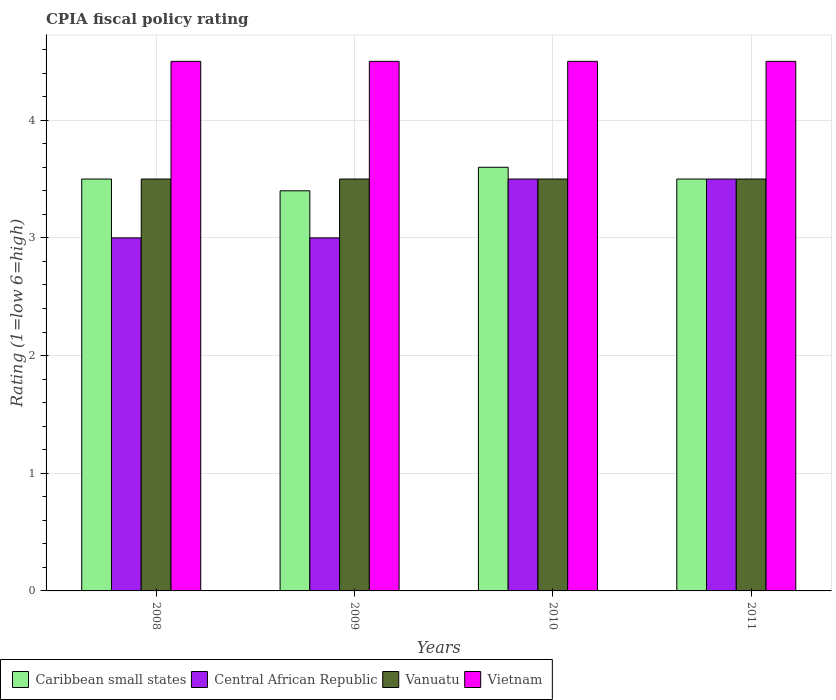How many groups of bars are there?
Provide a short and direct response. 4. Are the number of bars on each tick of the X-axis equal?
Keep it short and to the point. Yes. What is the label of the 4th group of bars from the left?
Your response must be concise. 2011. In how many cases, is the number of bars for a given year not equal to the number of legend labels?
Your answer should be very brief. 0. What is the CPIA rating in Central African Republic in 2008?
Offer a very short reply. 3. Across all years, what is the maximum CPIA rating in Vanuatu?
Offer a very short reply. 3.5. Across all years, what is the minimum CPIA rating in Vanuatu?
Offer a terse response. 3.5. In which year was the CPIA rating in Central African Republic maximum?
Provide a succinct answer. 2010. What is the total CPIA rating in Vietnam in the graph?
Offer a terse response. 18. What is the difference between the CPIA rating in Caribbean small states in 2008 and that in 2011?
Keep it short and to the point. 0. In how many years, is the CPIA rating in Central African Republic greater than 2.2?
Your response must be concise. 4. Is the CPIA rating in Vanuatu in 2009 less than that in 2011?
Offer a very short reply. No. Is the difference between the CPIA rating in Central African Republic in 2010 and 2011 greater than the difference between the CPIA rating in Vietnam in 2010 and 2011?
Keep it short and to the point. No. What is the difference between the highest and the lowest CPIA rating in Central African Republic?
Provide a succinct answer. 0.5. Is the sum of the CPIA rating in Vietnam in 2009 and 2011 greater than the maximum CPIA rating in Caribbean small states across all years?
Offer a very short reply. Yes. Is it the case that in every year, the sum of the CPIA rating in Vanuatu and CPIA rating in Central African Republic is greater than the sum of CPIA rating in Vietnam and CPIA rating in Caribbean small states?
Provide a short and direct response. No. What does the 2nd bar from the left in 2009 represents?
Offer a terse response. Central African Republic. What does the 1st bar from the right in 2009 represents?
Give a very brief answer. Vietnam. Is it the case that in every year, the sum of the CPIA rating in Central African Republic and CPIA rating in Vietnam is greater than the CPIA rating in Vanuatu?
Give a very brief answer. Yes. What is the difference between two consecutive major ticks on the Y-axis?
Offer a very short reply. 1. Are the values on the major ticks of Y-axis written in scientific E-notation?
Your answer should be very brief. No. Does the graph contain any zero values?
Offer a very short reply. No. Does the graph contain grids?
Keep it short and to the point. Yes. Where does the legend appear in the graph?
Give a very brief answer. Bottom left. What is the title of the graph?
Provide a short and direct response. CPIA fiscal policy rating. What is the label or title of the X-axis?
Offer a very short reply. Years. What is the label or title of the Y-axis?
Keep it short and to the point. Rating (1=low 6=high). What is the Rating (1=low 6=high) of Vanuatu in 2008?
Offer a terse response. 3.5. What is the Rating (1=low 6=high) of Vietnam in 2008?
Make the answer very short. 4.5. What is the Rating (1=low 6=high) of Vietnam in 2009?
Your answer should be very brief. 4.5. What is the Rating (1=low 6=high) in Caribbean small states in 2010?
Keep it short and to the point. 3.6. What is the Rating (1=low 6=high) of Central African Republic in 2010?
Your answer should be compact. 3.5. What is the Rating (1=low 6=high) in Caribbean small states in 2011?
Your response must be concise. 3.5. What is the Rating (1=low 6=high) of Vanuatu in 2011?
Offer a terse response. 3.5. What is the Rating (1=low 6=high) of Vietnam in 2011?
Your response must be concise. 4.5. Across all years, what is the minimum Rating (1=low 6=high) of Caribbean small states?
Keep it short and to the point. 3.4. Across all years, what is the minimum Rating (1=low 6=high) in Vietnam?
Your response must be concise. 4.5. What is the total Rating (1=low 6=high) in Caribbean small states in the graph?
Keep it short and to the point. 14. What is the total Rating (1=low 6=high) in Vietnam in the graph?
Provide a succinct answer. 18. What is the difference between the Rating (1=low 6=high) of Central African Republic in 2008 and that in 2009?
Ensure brevity in your answer.  0. What is the difference between the Rating (1=low 6=high) in Vietnam in 2008 and that in 2009?
Provide a short and direct response. 0. What is the difference between the Rating (1=low 6=high) in Caribbean small states in 2008 and that in 2010?
Keep it short and to the point. -0.1. What is the difference between the Rating (1=low 6=high) in Central African Republic in 2008 and that in 2010?
Give a very brief answer. -0.5. What is the difference between the Rating (1=low 6=high) of Vanuatu in 2008 and that in 2010?
Your answer should be compact. 0. What is the difference between the Rating (1=low 6=high) in Vietnam in 2008 and that in 2010?
Your answer should be compact. 0. What is the difference between the Rating (1=low 6=high) of Caribbean small states in 2008 and that in 2011?
Make the answer very short. 0. What is the difference between the Rating (1=low 6=high) of Vanuatu in 2008 and that in 2011?
Provide a short and direct response. 0. What is the difference between the Rating (1=low 6=high) of Vietnam in 2008 and that in 2011?
Give a very brief answer. 0. What is the difference between the Rating (1=low 6=high) of Caribbean small states in 2009 and that in 2010?
Your answer should be compact. -0.2. What is the difference between the Rating (1=low 6=high) of Caribbean small states in 2009 and that in 2011?
Your response must be concise. -0.1. What is the difference between the Rating (1=low 6=high) in Vanuatu in 2009 and that in 2011?
Your answer should be very brief. 0. What is the difference between the Rating (1=low 6=high) of Vietnam in 2009 and that in 2011?
Keep it short and to the point. 0. What is the difference between the Rating (1=low 6=high) of Caribbean small states in 2010 and that in 2011?
Your response must be concise. 0.1. What is the difference between the Rating (1=low 6=high) of Central African Republic in 2010 and that in 2011?
Your answer should be very brief. 0. What is the difference between the Rating (1=low 6=high) in Vanuatu in 2010 and that in 2011?
Offer a terse response. 0. What is the difference between the Rating (1=low 6=high) in Vietnam in 2010 and that in 2011?
Make the answer very short. 0. What is the difference between the Rating (1=low 6=high) in Caribbean small states in 2008 and the Rating (1=low 6=high) in Central African Republic in 2009?
Provide a short and direct response. 0.5. What is the difference between the Rating (1=low 6=high) of Central African Republic in 2008 and the Rating (1=low 6=high) of Vanuatu in 2009?
Your answer should be very brief. -0.5. What is the difference between the Rating (1=low 6=high) in Central African Republic in 2008 and the Rating (1=low 6=high) in Vietnam in 2009?
Your answer should be very brief. -1.5. What is the difference between the Rating (1=low 6=high) in Caribbean small states in 2008 and the Rating (1=low 6=high) in Vietnam in 2010?
Your response must be concise. -1. What is the difference between the Rating (1=low 6=high) in Central African Republic in 2008 and the Rating (1=low 6=high) in Vietnam in 2011?
Make the answer very short. -1.5. What is the difference between the Rating (1=low 6=high) in Vanuatu in 2008 and the Rating (1=low 6=high) in Vietnam in 2011?
Your answer should be compact. -1. What is the difference between the Rating (1=low 6=high) in Caribbean small states in 2009 and the Rating (1=low 6=high) in Central African Republic in 2010?
Offer a terse response. -0.1. What is the difference between the Rating (1=low 6=high) of Central African Republic in 2009 and the Rating (1=low 6=high) of Vietnam in 2010?
Offer a very short reply. -1.5. What is the difference between the Rating (1=low 6=high) of Caribbean small states in 2009 and the Rating (1=low 6=high) of Central African Republic in 2011?
Keep it short and to the point. -0.1. What is the difference between the Rating (1=low 6=high) of Vanuatu in 2009 and the Rating (1=low 6=high) of Vietnam in 2011?
Provide a short and direct response. -1. What is the difference between the Rating (1=low 6=high) in Caribbean small states in 2010 and the Rating (1=low 6=high) in Vanuatu in 2011?
Offer a terse response. 0.1. What is the difference between the Rating (1=low 6=high) in Caribbean small states in 2010 and the Rating (1=low 6=high) in Vietnam in 2011?
Offer a terse response. -0.9. What is the difference between the Rating (1=low 6=high) in Central African Republic in 2010 and the Rating (1=low 6=high) in Vanuatu in 2011?
Offer a terse response. 0. What is the difference between the Rating (1=low 6=high) in Central African Republic in 2010 and the Rating (1=low 6=high) in Vietnam in 2011?
Your answer should be compact. -1. What is the difference between the Rating (1=low 6=high) in Vanuatu in 2010 and the Rating (1=low 6=high) in Vietnam in 2011?
Offer a terse response. -1. What is the average Rating (1=low 6=high) in Central African Republic per year?
Keep it short and to the point. 3.25. What is the average Rating (1=low 6=high) of Vanuatu per year?
Provide a short and direct response. 3.5. In the year 2008, what is the difference between the Rating (1=low 6=high) in Caribbean small states and Rating (1=low 6=high) in Central African Republic?
Provide a short and direct response. 0.5. In the year 2008, what is the difference between the Rating (1=low 6=high) in Caribbean small states and Rating (1=low 6=high) in Vanuatu?
Provide a short and direct response. 0. In the year 2008, what is the difference between the Rating (1=low 6=high) of Caribbean small states and Rating (1=low 6=high) of Vietnam?
Make the answer very short. -1. In the year 2008, what is the difference between the Rating (1=low 6=high) of Central African Republic and Rating (1=low 6=high) of Vietnam?
Provide a short and direct response. -1.5. In the year 2009, what is the difference between the Rating (1=low 6=high) of Caribbean small states and Rating (1=low 6=high) of Vanuatu?
Give a very brief answer. -0.1. In the year 2009, what is the difference between the Rating (1=low 6=high) in Caribbean small states and Rating (1=low 6=high) in Vietnam?
Your response must be concise. -1.1. In the year 2009, what is the difference between the Rating (1=low 6=high) in Vanuatu and Rating (1=low 6=high) in Vietnam?
Your answer should be compact. -1. In the year 2010, what is the difference between the Rating (1=low 6=high) in Caribbean small states and Rating (1=low 6=high) in Central African Republic?
Your answer should be very brief. 0.1. In the year 2010, what is the difference between the Rating (1=low 6=high) of Caribbean small states and Rating (1=low 6=high) of Vanuatu?
Give a very brief answer. 0.1. In the year 2010, what is the difference between the Rating (1=low 6=high) in Caribbean small states and Rating (1=low 6=high) in Vietnam?
Provide a succinct answer. -0.9. In the year 2010, what is the difference between the Rating (1=low 6=high) of Central African Republic and Rating (1=low 6=high) of Vanuatu?
Ensure brevity in your answer.  0. In the year 2010, what is the difference between the Rating (1=low 6=high) of Central African Republic and Rating (1=low 6=high) of Vietnam?
Your answer should be compact. -1. In the year 2011, what is the difference between the Rating (1=low 6=high) of Caribbean small states and Rating (1=low 6=high) of Central African Republic?
Provide a succinct answer. 0. In the year 2011, what is the difference between the Rating (1=low 6=high) in Caribbean small states and Rating (1=low 6=high) in Vanuatu?
Your response must be concise. 0. In the year 2011, what is the difference between the Rating (1=low 6=high) of Central African Republic and Rating (1=low 6=high) of Vietnam?
Provide a short and direct response. -1. What is the ratio of the Rating (1=low 6=high) in Caribbean small states in 2008 to that in 2009?
Your response must be concise. 1.03. What is the ratio of the Rating (1=low 6=high) in Vietnam in 2008 to that in 2009?
Make the answer very short. 1. What is the ratio of the Rating (1=low 6=high) in Caribbean small states in 2008 to that in 2010?
Your answer should be very brief. 0.97. What is the ratio of the Rating (1=low 6=high) in Vanuatu in 2008 to that in 2010?
Ensure brevity in your answer.  1. What is the ratio of the Rating (1=low 6=high) of Central African Republic in 2008 to that in 2011?
Offer a very short reply. 0.86. What is the ratio of the Rating (1=low 6=high) in Vanuatu in 2008 to that in 2011?
Provide a short and direct response. 1. What is the ratio of the Rating (1=low 6=high) of Vietnam in 2008 to that in 2011?
Give a very brief answer. 1. What is the ratio of the Rating (1=low 6=high) in Caribbean small states in 2009 to that in 2010?
Offer a terse response. 0.94. What is the ratio of the Rating (1=low 6=high) in Vanuatu in 2009 to that in 2010?
Make the answer very short. 1. What is the ratio of the Rating (1=low 6=high) in Caribbean small states in 2009 to that in 2011?
Provide a short and direct response. 0.97. What is the ratio of the Rating (1=low 6=high) of Caribbean small states in 2010 to that in 2011?
Your answer should be compact. 1.03. What is the ratio of the Rating (1=low 6=high) in Central African Republic in 2010 to that in 2011?
Ensure brevity in your answer.  1. What is the difference between the highest and the second highest Rating (1=low 6=high) in Central African Republic?
Your answer should be compact. 0. What is the difference between the highest and the second highest Rating (1=low 6=high) in Vanuatu?
Your response must be concise. 0. What is the difference between the highest and the lowest Rating (1=low 6=high) in Vietnam?
Offer a terse response. 0. 